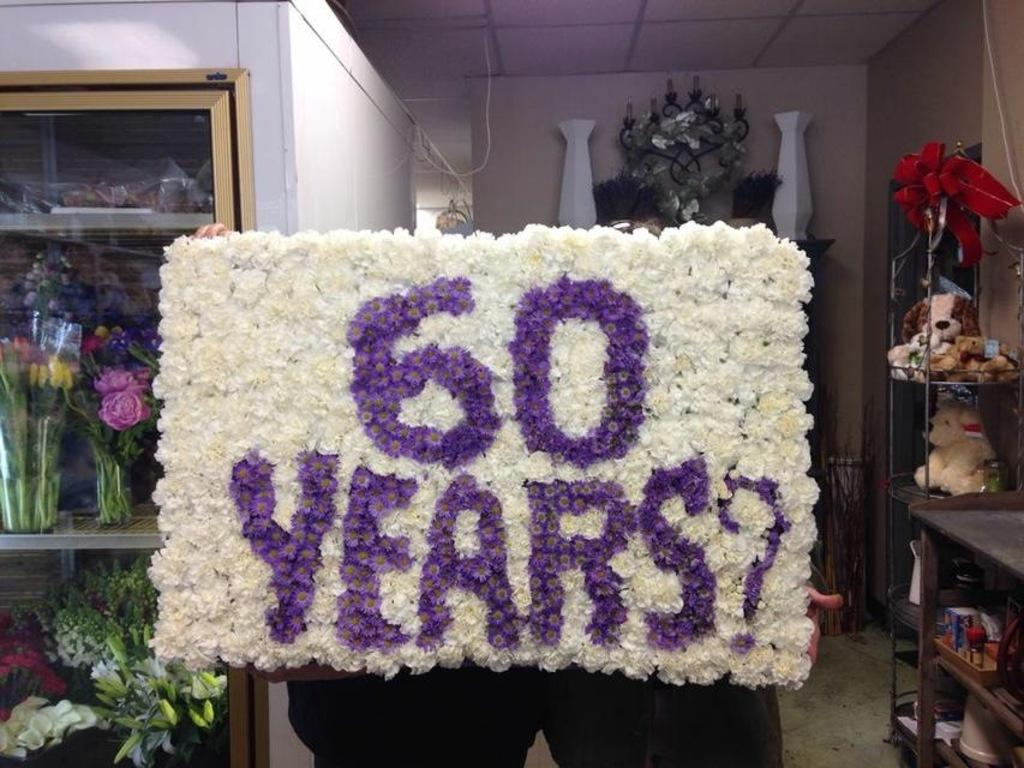<image>
Present a compact description of the photo's key features. A floral arrangement says "60 years" as a question. 